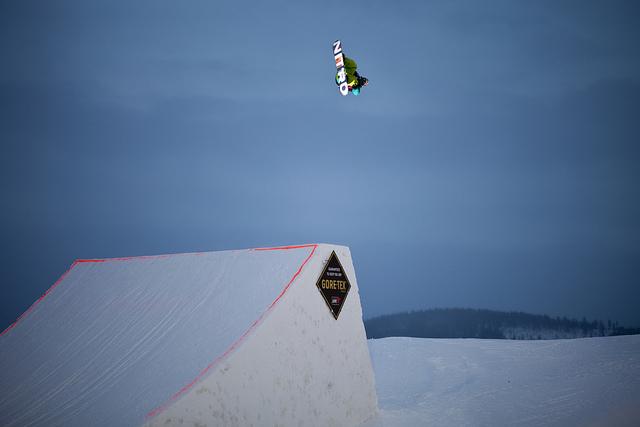Does this athlete appear to be a novice or expert?
Be succinct. Expert. Is there a wing in the image?
Short answer required. No. What sport is taking place in the scene?
Short answer required. Snowboarding. How high is the skater?
Short answer required. High. Is the landscape flat?
Answer briefly. No. 